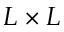<formula> <loc_0><loc_0><loc_500><loc_500>L \times L</formula> 